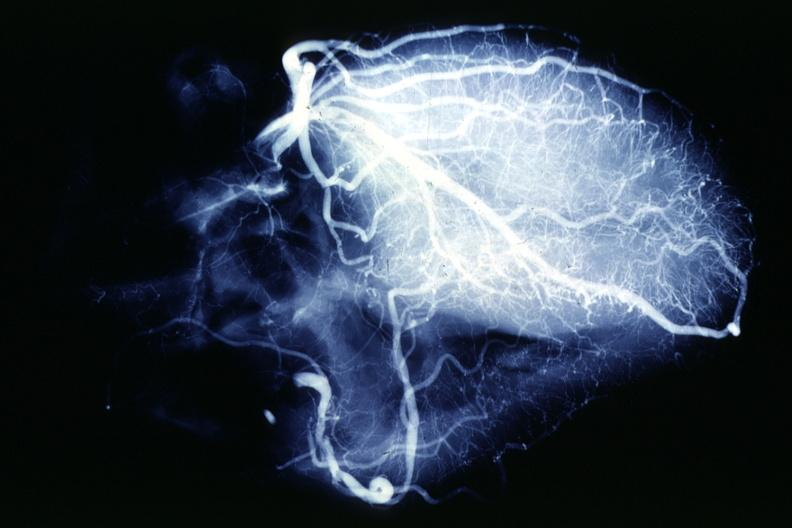what is present?
Answer the question using a single word or phrase. Cardiovascular 